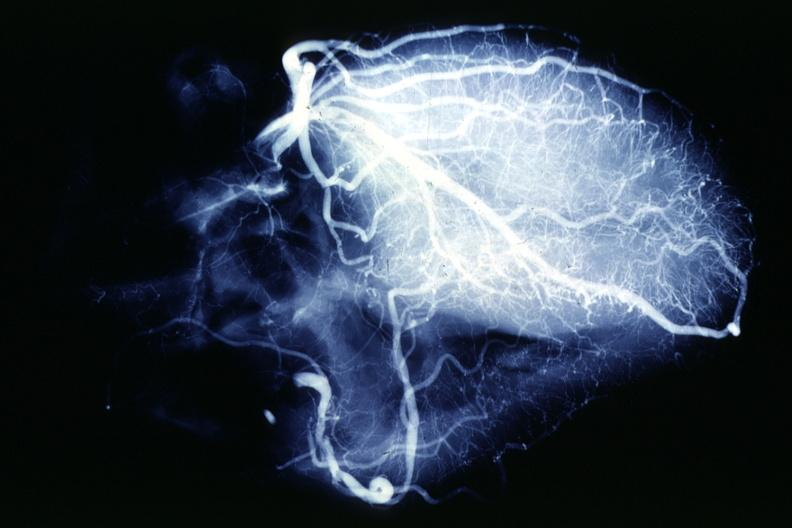what is present?
Answer the question using a single word or phrase. Cardiovascular 